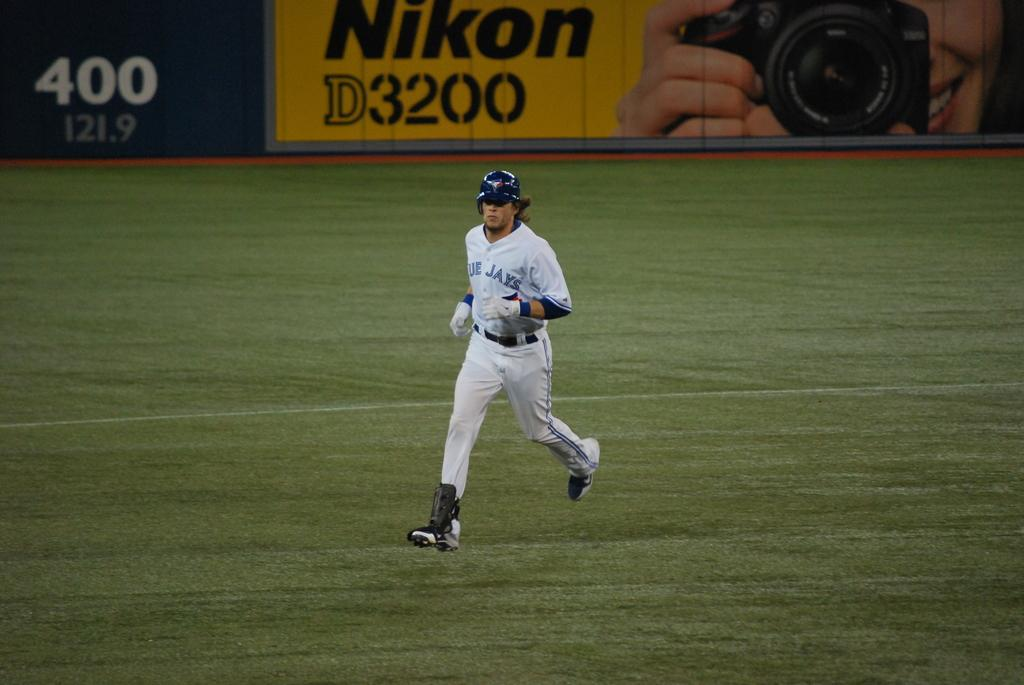<image>
Summarize the visual content of the image. A Blue Jays player runs across the grassy field. 